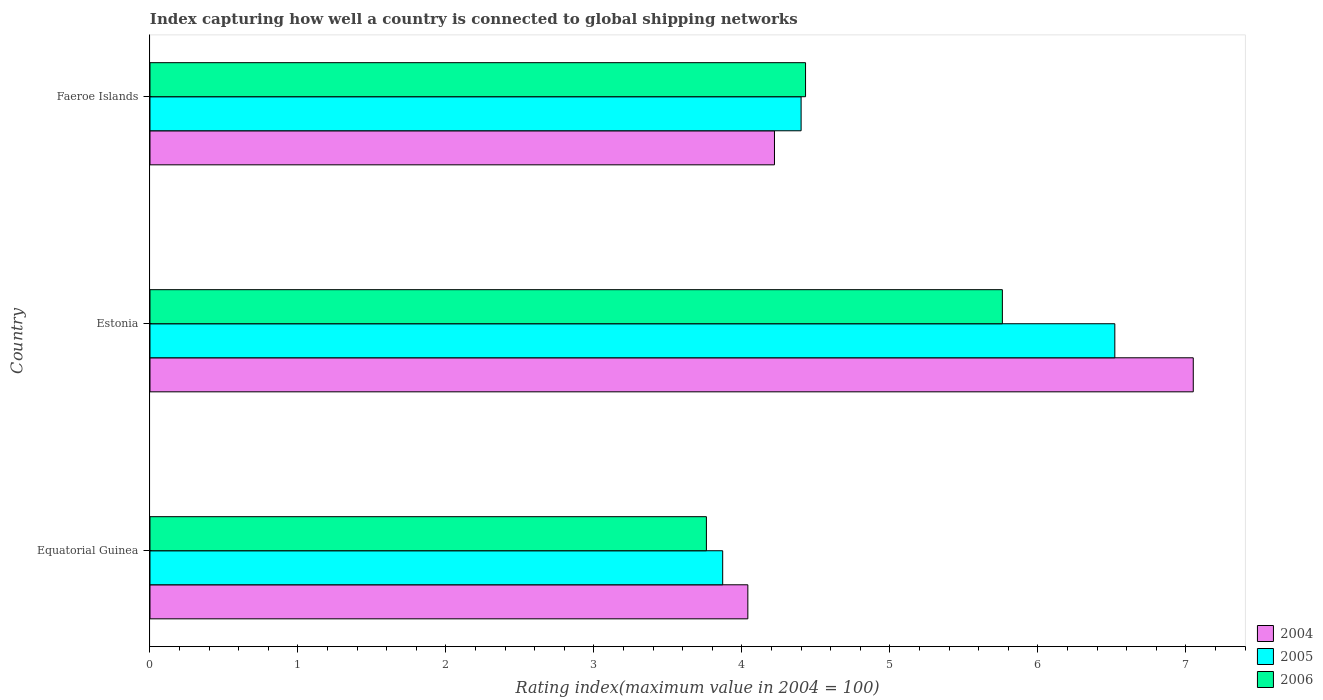How many groups of bars are there?
Provide a short and direct response. 3. Are the number of bars on each tick of the Y-axis equal?
Provide a short and direct response. Yes. What is the label of the 3rd group of bars from the top?
Keep it short and to the point. Equatorial Guinea. What is the rating index in 2006 in Equatorial Guinea?
Ensure brevity in your answer.  3.76. Across all countries, what is the maximum rating index in 2006?
Offer a terse response. 5.76. Across all countries, what is the minimum rating index in 2006?
Provide a succinct answer. 3.76. In which country was the rating index in 2004 maximum?
Make the answer very short. Estonia. In which country was the rating index in 2004 minimum?
Your response must be concise. Equatorial Guinea. What is the total rating index in 2004 in the graph?
Make the answer very short. 15.31. What is the difference between the rating index in 2006 in Equatorial Guinea and that in Faeroe Islands?
Give a very brief answer. -0.67. What is the difference between the rating index in 2004 in Equatorial Guinea and the rating index in 2005 in Estonia?
Make the answer very short. -2.48. What is the average rating index in 2005 per country?
Your answer should be compact. 4.93. What is the difference between the rating index in 2006 and rating index in 2005 in Faeroe Islands?
Your answer should be compact. 0.03. What is the ratio of the rating index in 2005 in Equatorial Guinea to that in Faeroe Islands?
Your response must be concise. 0.88. What is the difference between the highest and the second highest rating index in 2006?
Ensure brevity in your answer.  1.33. What is the difference between the highest and the lowest rating index in 2005?
Your answer should be compact. 2.65. In how many countries, is the rating index in 2004 greater than the average rating index in 2004 taken over all countries?
Provide a succinct answer. 1. What does the 2nd bar from the bottom in Estonia represents?
Keep it short and to the point. 2005. How many bars are there?
Your response must be concise. 9. What is the difference between two consecutive major ticks on the X-axis?
Offer a terse response. 1. Does the graph contain grids?
Your answer should be compact. No. Where does the legend appear in the graph?
Your response must be concise. Bottom right. How are the legend labels stacked?
Offer a very short reply. Vertical. What is the title of the graph?
Give a very brief answer. Index capturing how well a country is connected to global shipping networks. Does "1967" appear as one of the legend labels in the graph?
Your answer should be very brief. No. What is the label or title of the X-axis?
Your answer should be very brief. Rating index(maximum value in 2004 = 100). What is the Rating index(maximum value in 2004 = 100) of 2004 in Equatorial Guinea?
Ensure brevity in your answer.  4.04. What is the Rating index(maximum value in 2004 = 100) in 2005 in Equatorial Guinea?
Your answer should be very brief. 3.87. What is the Rating index(maximum value in 2004 = 100) of 2006 in Equatorial Guinea?
Offer a very short reply. 3.76. What is the Rating index(maximum value in 2004 = 100) of 2004 in Estonia?
Offer a terse response. 7.05. What is the Rating index(maximum value in 2004 = 100) of 2005 in Estonia?
Your answer should be compact. 6.52. What is the Rating index(maximum value in 2004 = 100) in 2006 in Estonia?
Your answer should be compact. 5.76. What is the Rating index(maximum value in 2004 = 100) in 2004 in Faeroe Islands?
Provide a short and direct response. 4.22. What is the Rating index(maximum value in 2004 = 100) in 2006 in Faeroe Islands?
Make the answer very short. 4.43. Across all countries, what is the maximum Rating index(maximum value in 2004 = 100) of 2004?
Offer a terse response. 7.05. Across all countries, what is the maximum Rating index(maximum value in 2004 = 100) of 2005?
Keep it short and to the point. 6.52. Across all countries, what is the maximum Rating index(maximum value in 2004 = 100) of 2006?
Give a very brief answer. 5.76. Across all countries, what is the minimum Rating index(maximum value in 2004 = 100) in 2004?
Make the answer very short. 4.04. Across all countries, what is the minimum Rating index(maximum value in 2004 = 100) in 2005?
Keep it short and to the point. 3.87. Across all countries, what is the minimum Rating index(maximum value in 2004 = 100) of 2006?
Your answer should be compact. 3.76. What is the total Rating index(maximum value in 2004 = 100) in 2004 in the graph?
Give a very brief answer. 15.31. What is the total Rating index(maximum value in 2004 = 100) of 2005 in the graph?
Your response must be concise. 14.79. What is the total Rating index(maximum value in 2004 = 100) in 2006 in the graph?
Keep it short and to the point. 13.95. What is the difference between the Rating index(maximum value in 2004 = 100) in 2004 in Equatorial Guinea and that in Estonia?
Your response must be concise. -3.01. What is the difference between the Rating index(maximum value in 2004 = 100) in 2005 in Equatorial Guinea and that in Estonia?
Make the answer very short. -2.65. What is the difference between the Rating index(maximum value in 2004 = 100) of 2006 in Equatorial Guinea and that in Estonia?
Offer a terse response. -2. What is the difference between the Rating index(maximum value in 2004 = 100) of 2004 in Equatorial Guinea and that in Faeroe Islands?
Ensure brevity in your answer.  -0.18. What is the difference between the Rating index(maximum value in 2004 = 100) of 2005 in Equatorial Guinea and that in Faeroe Islands?
Your answer should be compact. -0.53. What is the difference between the Rating index(maximum value in 2004 = 100) of 2006 in Equatorial Guinea and that in Faeroe Islands?
Provide a succinct answer. -0.67. What is the difference between the Rating index(maximum value in 2004 = 100) of 2004 in Estonia and that in Faeroe Islands?
Provide a short and direct response. 2.83. What is the difference between the Rating index(maximum value in 2004 = 100) in 2005 in Estonia and that in Faeroe Islands?
Provide a short and direct response. 2.12. What is the difference between the Rating index(maximum value in 2004 = 100) of 2006 in Estonia and that in Faeroe Islands?
Your answer should be compact. 1.33. What is the difference between the Rating index(maximum value in 2004 = 100) of 2004 in Equatorial Guinea and the Rating index(maximum value in 2004 = 100) of 2005 in Estonia?
Provide a succinct answer. -2.48. What is the difference between the Rating index(maximum value in 2004 = 100) of 2004 in Equatorial Guinea and the Rating index(maximum value in 2004 = 100) of 2006 in Estonia?
Give a very brief answer. -1.72. What is the difference between the Rating index(maximum value in 2004 = 100) in 2005 in Equatorial Guinea and the Rating index(maximum value in 2004 = 100) in 2006 in Estonia?
Provide a succinct answer. -1.89. What is the difference between the Rating index(maximum value in 2004 = 100) in 2004 in Equatorial Guinea and the Rating index(maximum value in 2004 = 100) in 2005 in Faeroe Islands?
Ensure brevity in your answer.  -0.36. What is the difference between the Rating index(maximum value in 2004 = 100) in 2004 in Equatorial Guinea and the Rating index(maximum value in 2004 = 100) in 2006 in Faeroe Islands?
Make the answer very short. -0.39. What is the difference between the Rating index(maximum value in 2004 = 100) in 2005 in Equatorial Guinea and the Rating index(maximum value in 2004 = 100) in 2006 in Faeroe Islands?
Your answer should be compact. -0.56. What is the difference between the Rating index(maximum value in 2004 = 100) in 2004 in Estonia and the Rating index(maximum value in 2004 = 100) in 2005 in Faeroe Islands?
Make the answer very short. 2.65. What is the difference between the Rating index(maximum value in 2004 = 100) in 2004 in Estonia and the Rating index(maximum value in 2004 = 100) in 2006 in Faeroe Islands?
Make the answer very short. 2.62. What is the difference between the Rating index(maximum value in 2004 = 100) in 2005 in Estonia and the Rating index(maximum value in 2004 = 100) in 2006 in Faeroe Islands?
Offer a very short reply. 2.09. What is the average Rating index(maximum value in 2004 = 100) in 2004 per country?
Your response must be concise. 5.1. What is the average Rating index(maximum value in 2004 = 100) of 2005 per country?
Your answer should be compact. 4.93. What is the average Rating index(maximum value in 2004 = 100) in 2006 per country?
Your answer should be very brief. 4.65. What is the difference between the Rating index(maximum value in 2004 = 100) of 2004 and Rating index(maximum value in 2004 = 100) of 2005 in Equatorial Guinea?
Your response must be concise. 0.17. What is the difference between the Rating index(maximum value in 2004 = 100) in 2004 and Rating index(maximum value in 2004 = 100) in 2006 in Equatorial Guinea?
Make the answer very short. 0.28. What is the difference between the Rating index(maximum value in 2004 = 100) of 2005 and Rating index(maximum value in 2004 = 100) of 2006 in Equatorial Guinea?
Offer a very short reply. 0.11. What is the difference between the Rating index(maximum value in 2004 = 100) of 2004 and Rating index(maximum value in 2004 = 100) of 2005 in Estonia?
Make the answer very short. 0.53. What is the difference between the Rating index(maximum value in 2004 = 100) in 2004 and Rating index(maximum value in 2004 = 100) in 2006 in Estonia?
Keep it short and to the point. 1.29. What is the difference between the Rating index(maximum value in 2004 = 100) of 2005 and Rating index(maximum value in 2004 = 100) of 2006 in Estonia?
Ensure brevity in your answer.  0.76. What is the difference between the Rating index(maximum value in 2004 = 100) of 2004 and Rating index(maximum value in 2004 = 100) of 2005 in Faeroe Islands?
Your answer should be very brief. -0.18. What is the difference between the Rating index(maximum value in 2004 = 100) in 2004 and Rating index(maximum value in 2004 = 100) in 2006 in Faeroe Islands?
Your answer should be very brief. -0.21. What is the difference between the Rating index(maximum value in 2004 = 100) of 2005 and Rating index(maximum value in 2004 = 100) of 2006 in Faeroe Islands?
Your answer should be compact. -0.03. What is the ratio of the Rating index(maximum value in 2004 = 100) in 2004 in Equatorial Guinea to that in Estonia?
Your answer should be compact. 0.57. What is the ratio of the Rating index(maximum value in 2004 = 100) of 2005 in Equatorial Guinea to that in Estonia?
Make the answer very short. 0.59. What is the ratio of the Rating index(maximum value in 2004 = 100) of 2006 in Equatorial Guinea to that in Estonia?
Offer a terse response. 0.65. What is the ratio of the Rating index(maximum value in 2004 = 100) in 2004 in Equatorial Guinea to that in Faeroe Islands?
Make the answer very short. 0.96. What is the ratio of the Rating index(maximum value in 2004 = 100) of 2005 in Equatorial Guinea to that in Faeroe Islands?
Make the answer very short. 0.88. What is the ratio of the Rating index(maximum value in 2004 = 100) of 2006 in Equatorial Guinea to that in Faeroe Islands?
Ensure brevity in your answer.  0.85. What is the ratio of the Rating index(maximum value in 2004 = 100) in 2004 in Estonia to that in Faeroe Islands?
Provide a succinct answer. 1.67. What is the ratio of the Rating index(maximum value in 2004 = 100) of 2005 in Estonia to that in Faeroe Islands?
Your answer should be very brief. 1.48. What is the ratio of the Rating index(maximum value in 2004 = 100) of 2006 in Estonia to that in Faeroe Islands?
Your answer should be compact. 1.3. What is the difference between the highest and the second highest Rating index(maximum value in 2004 = 100) of 2004?
Make the answer very short. 2.83. What is the difference between the highest and the second highest Rating index(maximum value in 2004 = 100) in 2005?
Give a very brief answer. 2.12. What is the difference between the highest and the second highest Rating index(maximum value in 2004 = 100) of 2006?
Provide a short and direct response. 1.33. What is the difference between the highest and the lowest Rating index(maximum value in 2004 = 100) in 2004?
Give a very brief answer. 3.01. What is the difference between the highest and the lowest Rating index(maximum value in 2004 = 100) of 2005?
Your response must be concise. 2.65. 